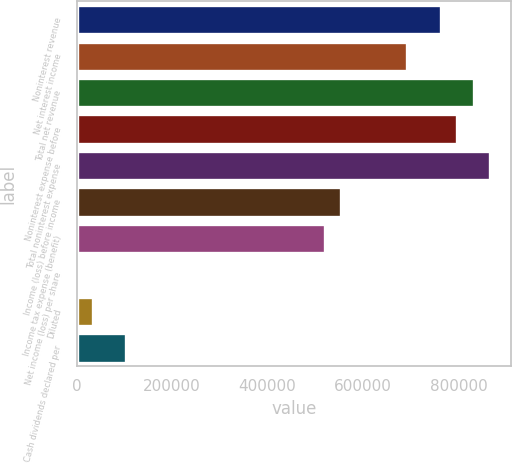Convert chart to OTSL. <chart><loc_0><loc_0><loc_500><loc_500><bar_chart><fcel>Noninterest revenue<fcel>Net interest income<fcel>Total net revenue<fcel>Noninterest expense before<fcel>Total noninterest expense<fcel>Income (loss) before income<fcel>Income tax expense (benefit)<fcel>Net income (loss) per share<fcel>Diluted<fcel>Cash dividends declared per<nl><fcel>762385<fcel>693078<fcel>831693<fcel>797039<fcel>866347<fcel>554462<fcel>519808<fcel>0.27<fcel>34654.1<fcel>103962<nl></chart> 